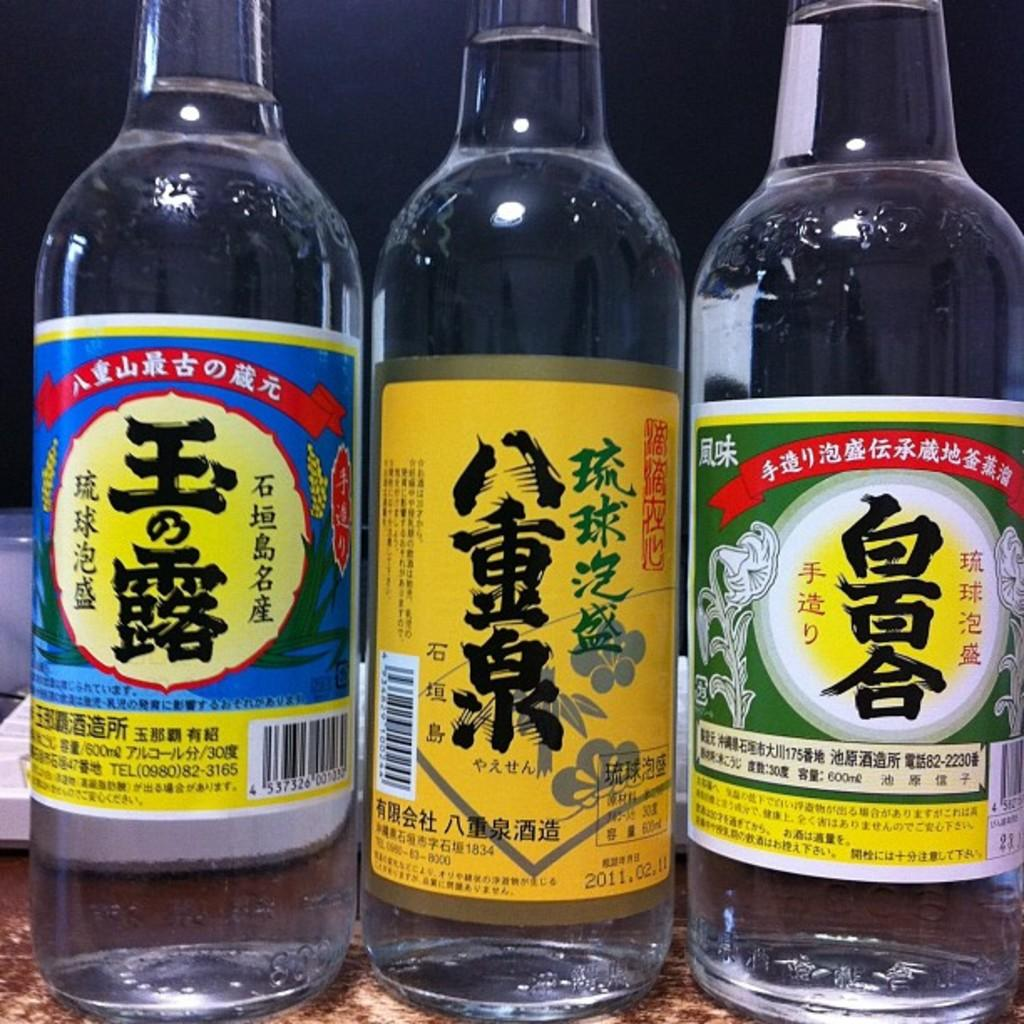Provide a one-sentence caption for the provided image. Three bottles with clear liquid in them and japanese or chinese writing. 